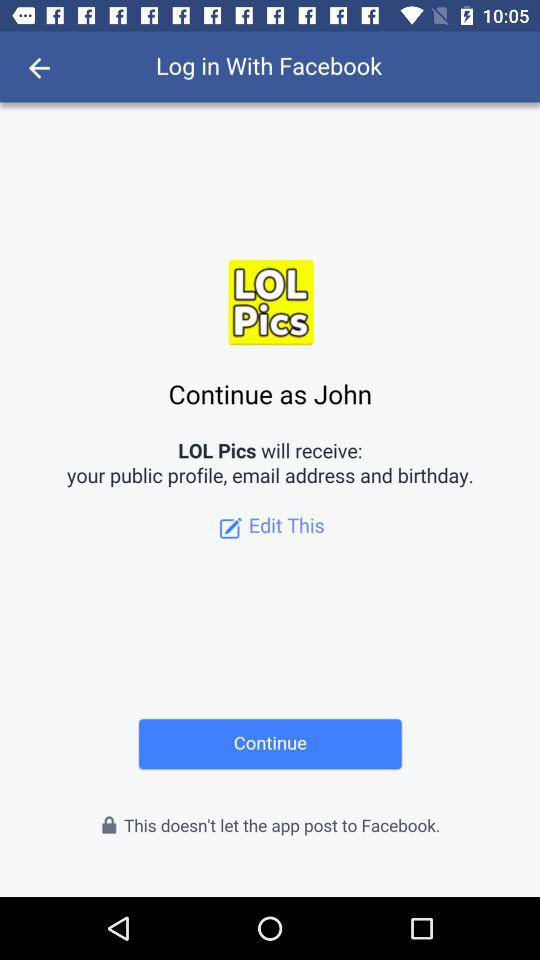Who will receive the public figure and email address? The one who will receive the public figure and email address is "LOL Pics". 